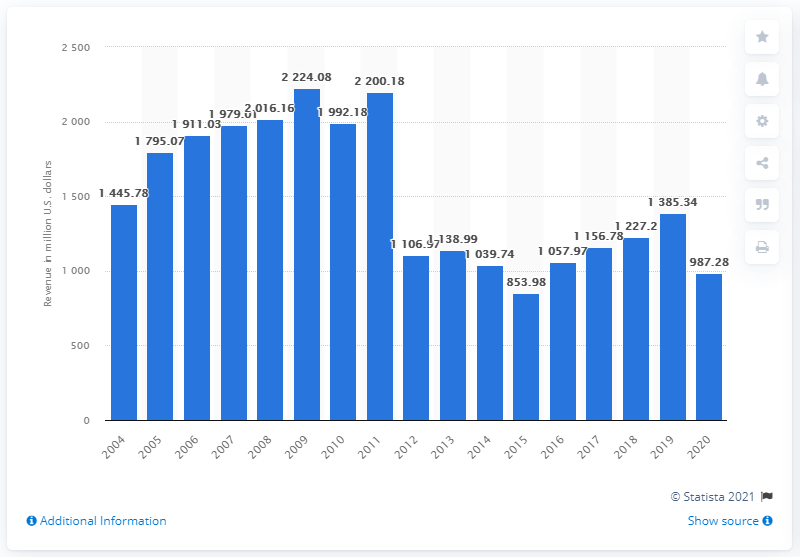Outline some significant characteristics in this image. Envoy Air generated a total revenue of 987.28 million dollars in 2020. 